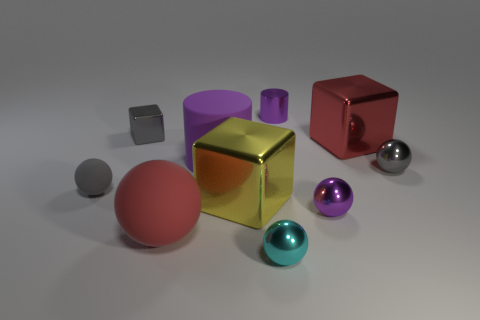Subtract 2 balls. How many balls are left? 3 Subtract all blue balls. Subtract all red cubes. How many balls are left? 5 Subtract all blocks. How many objects are left? 7 Subtract 0 green spheres. How many objects are left? 10 Subtract all large purple cylinders. Subtract all small gray cubes. How many objects are left? 8 Add 6 metallic cylinders. How many metallic cylinders are left? 7 Add 2 small brown blocks. How many small brown blocks exist? 2 